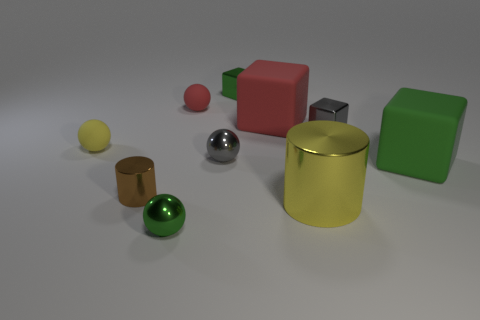There is a matte object that is the same color as the big cylinder; what is its size?
Provide a succinct answer. Small. Is there any other thing that has the same material as the large yellow object?
Your answer should be compact. Yes. Is the size of the yellow object to the left of the big cylinder the same as the cylinder right of the tiny brown cylinder?
Offer a terse response. No. What number of large objects are either yellow metallic spheres or yellow balls?
Provide a short and direct response. 0. How many small metallic things are on the right side of the green metal block and on the left side of the big yellow metallic object?
Keep it short and to the point. 0. Are the small red ball and the big object that is in front of the small cylinder made of the same material?
Ensure brevity in your answer.  No. What number of gray things are shiny balls or small blocks?
Ensure brevity in your answer.  2. Is there a gray sphere that has the same size as the yellow cylinder?
Keep it short and to the point. No. What material is the cylinder that is on the right side of the metal sphere on the left side of the small matte object that is right of the small brown metal cylinder?
Your response must be concise. Metal. Are there an equal number of tiny brown shiny things that are behind the red rubber cube and large gray metal objects?
Offer a very short reply. Yes. 